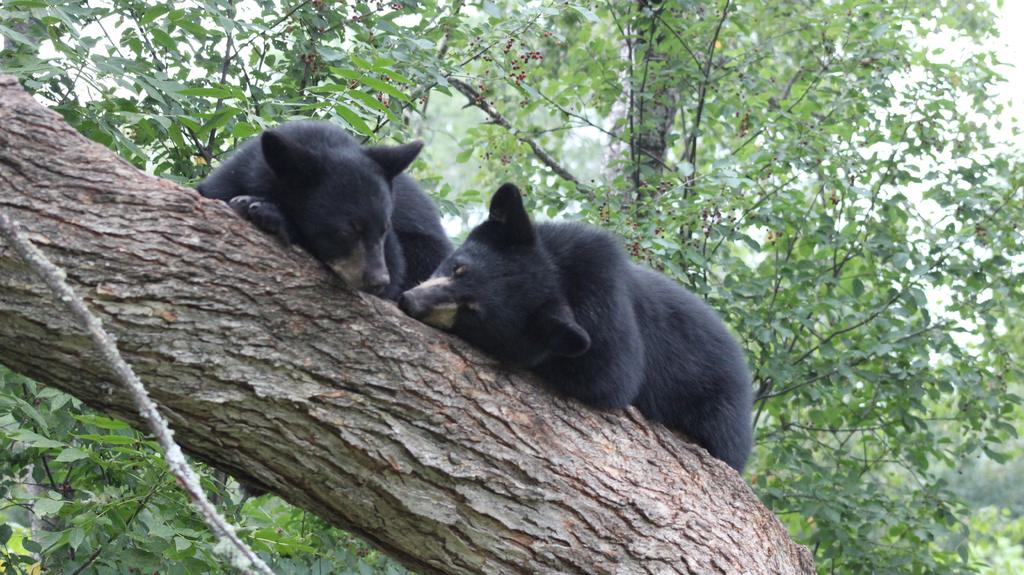What animals are in the foreground of the image? There are two black bears in the foreground of the image. What are the black bears doing in the image? The black bears are on a tree trunk. What can be seen in the background of the image? There are trees visible in the background of the image. What type of cannon can be seen in the image? There is no cannon present in the image; it features two black bears on a tree trunk. How many times do the black bears smash the land in the image? The black bears are not shown smashing the land in the image; they are simply sitting on a tree trunk. 